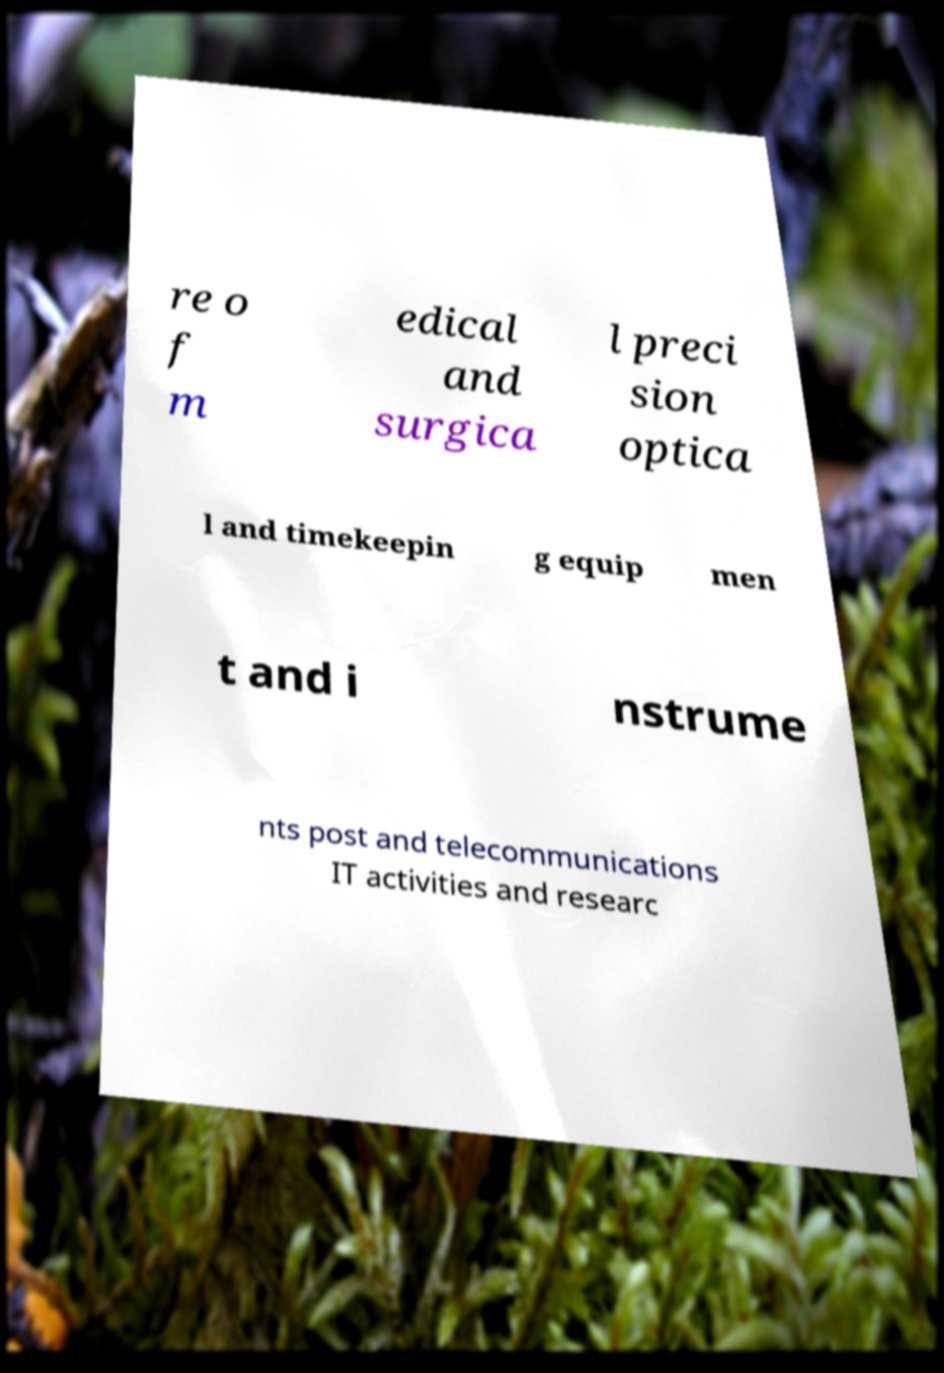Please read and relay the text visible in this image. What does it say? re o f m edical and surgica l preci sion optica l and timekeepin g equip men t and i nstrume nts post and telecommunications IT activities and researc 